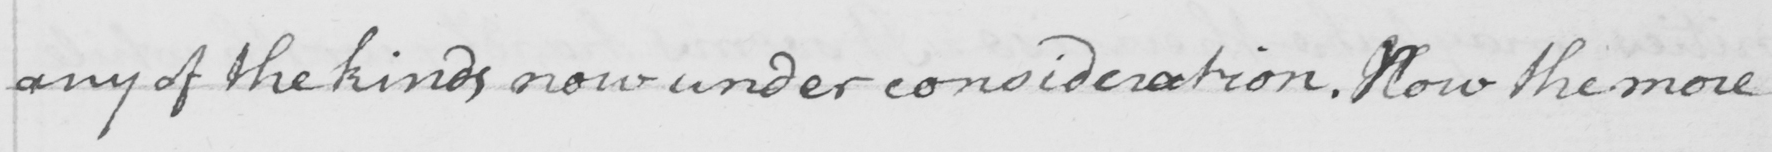Can you tell me what this handwritten text says? any of the kinds now under consideration . Now the more 